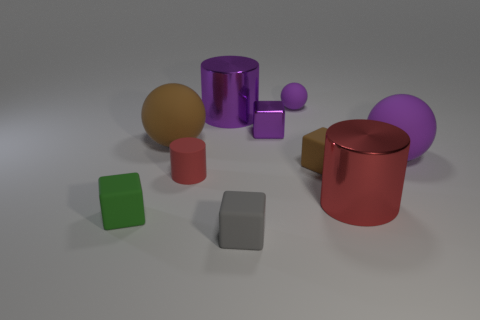Is there anything else that is the same shape as the tiny red object?
Your response must be concise. Yes. Is there a large cylinder of the same color as the small metal thing?
Provide a short and direct response. Yes. Are the cube that is left of the gray rubber object and the tiny object that is in front of the small green matte thing made of the same material?
Give a very brief answer. Yes. What color is the tiny cylinder?
Offer a terse response. Red. How big is the thing that is to the right of the shiny cylinder to the right of the tiny cube that is in front of the tiny green object?
Your answer should be compact. Large. How many other things are the same size as the green rubber object?
Your answer should be very brief. 5. How many purple cylinders are made of the same material as the big brown object?
Make the answer very short. 0. What is the shape of the big shiny thing that is behind the brown rubber cube?
Offer a very short reply. Cylinder. Are the brown sphere and the purple object that is on the right side of the big red shiny cylinder made of the same material?
Your response must be concise. Yes. Are any yellow metallic cylinders visible?
Keep it short and to the point. No. 